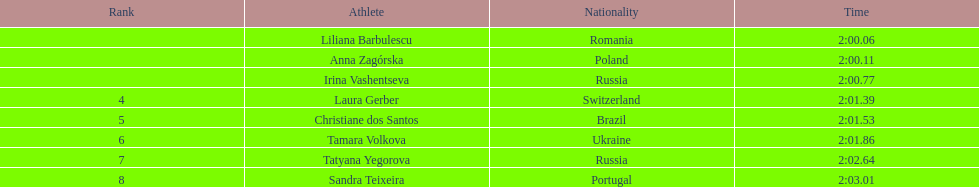Who took part in the sports competition? Liliana Barbulescu, 2:00.06, Anna Zagórska, 2:00.11, Irina Vashentseva, 2:00.77, Laura Gerber, 2:01.39, Christiane dos Santos, 2:01.53, Tamara Volkova, 2:01.86, Tatyana Yegorova, 2:02.64, Sandra Teixeira, 2:03.01. Who secured the runner-up position? Anna Zagórska, 2:00.11. What was her recorded time? 2:00.11. 